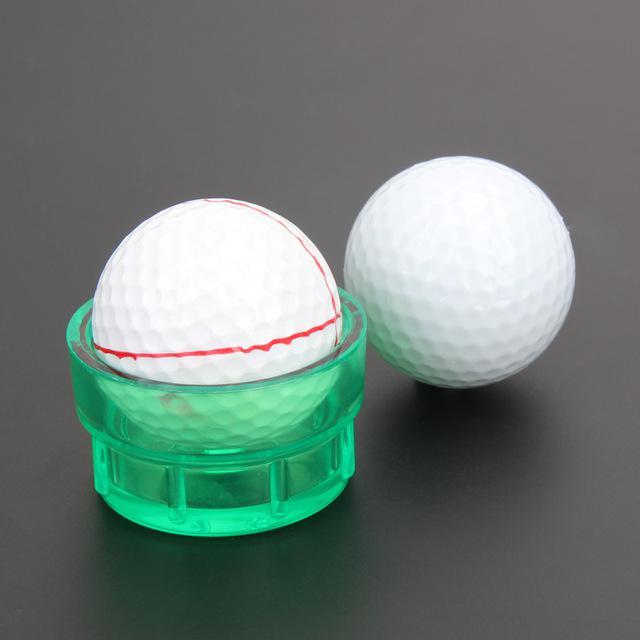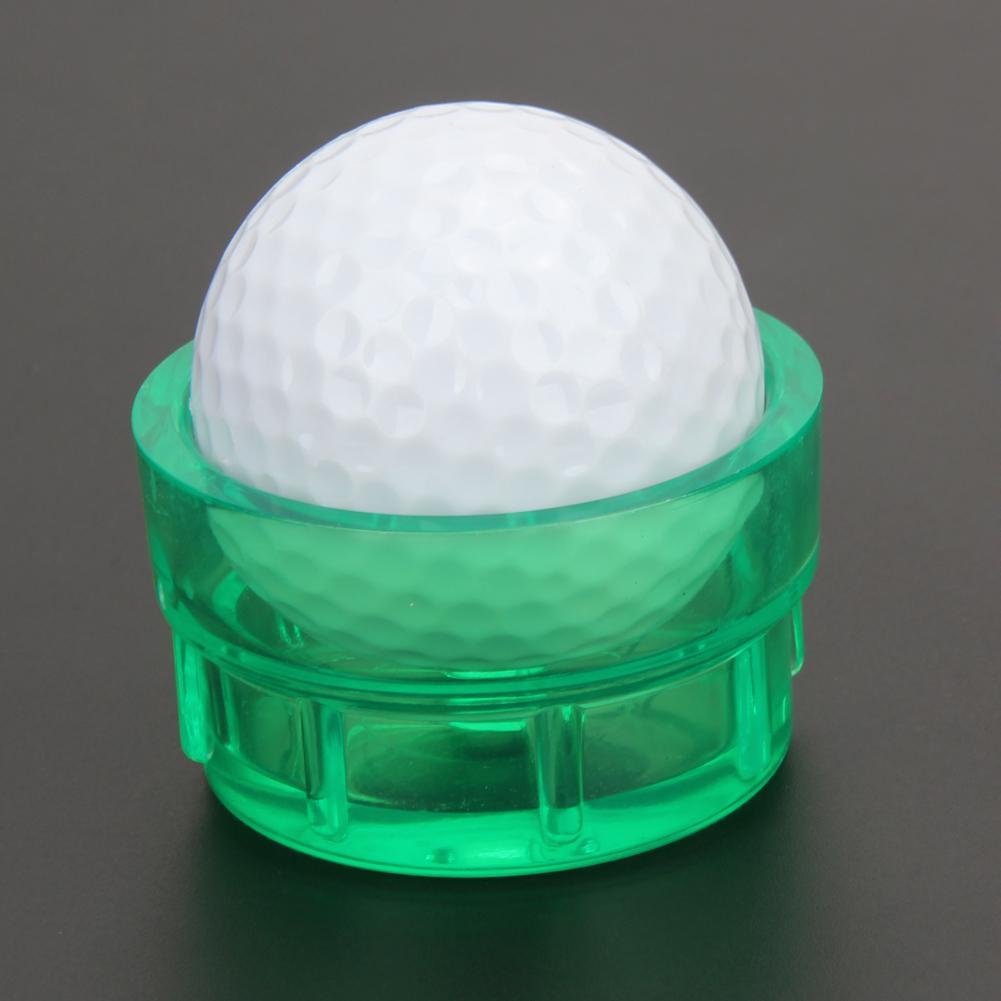The first image is the image on the left, the second image is the image on the right. Assess this claim about the two images: "There are only two golf balls, and both of them are in translucent green containers.". Correct or not? Answer yes or no. No. The first image is the image on the left, the second image is the image on the right. For the images displayed, is the sentence "In one of the images there is a golf ball with red lines on it." factually correct? Answer yes or no. Yes. 